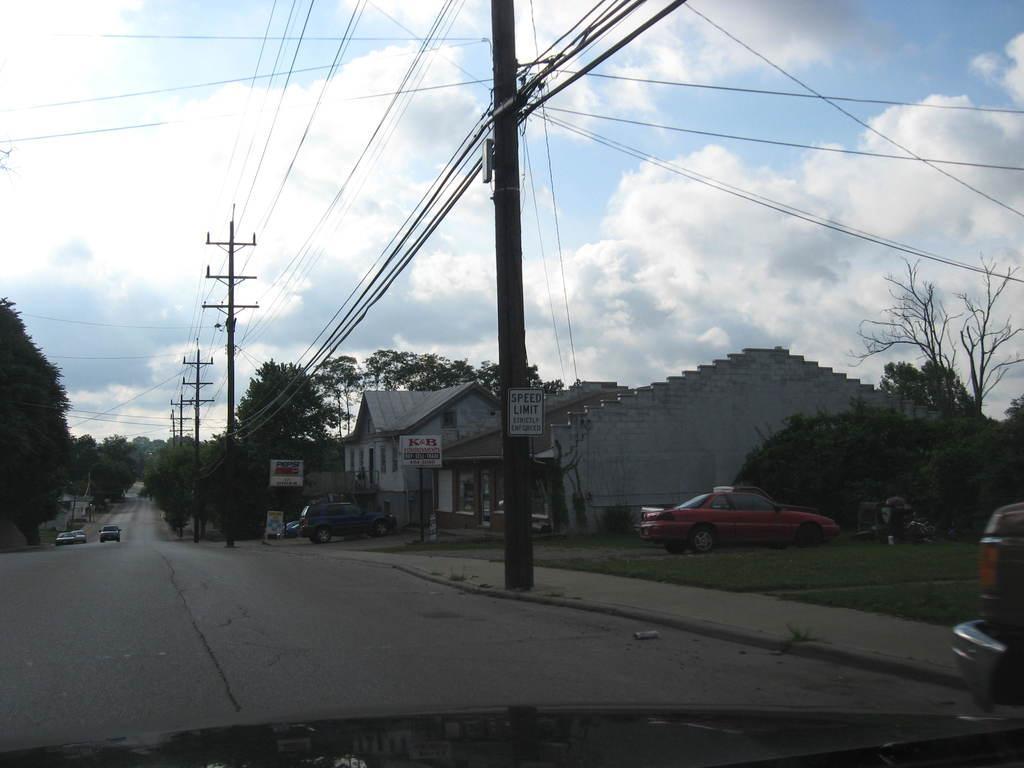In one or two sentences, can you explain what this image depicts? In this picture we can see cars on the road, poles, trees, houses, grass, signboard, name boards, wires and in the background we can see the sky with clouds. 